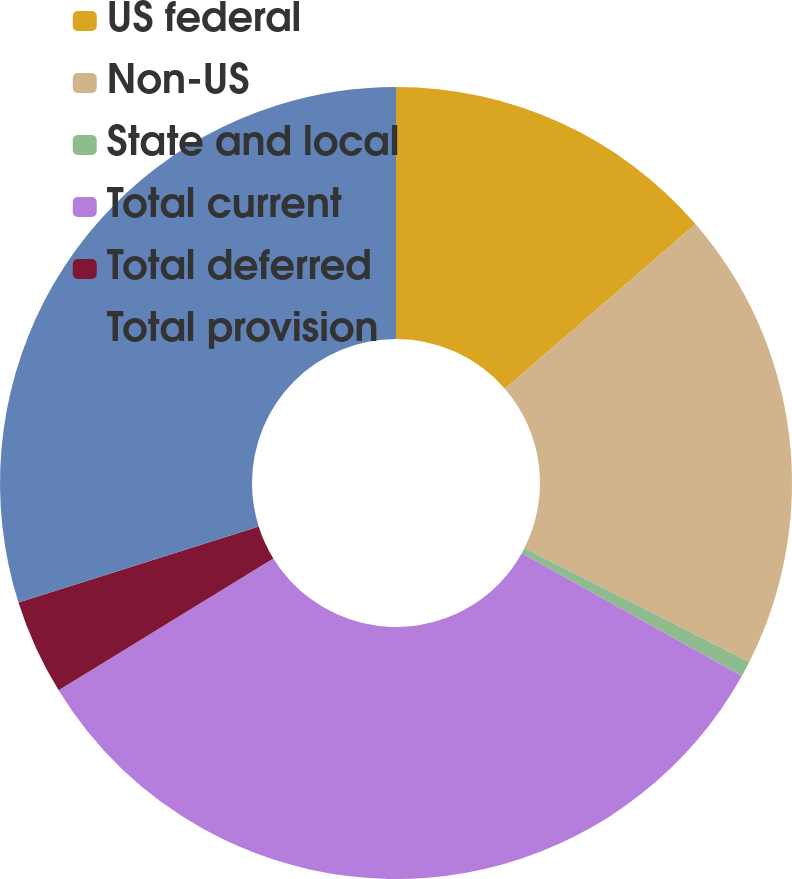<chart> <loc_0><loc_0><loc_500><loc_500><pie_chart><fcel>US federal<fcel>Non-US<fcel>State and local<fcel>Total current<fcel>Total deferred<fcel>Total provision<nl><fcel>13.65%<fcel>18.81%<fcel>0.64%<fcel>33.13%<fcel>3.89%<fcel>29.88%<nl></chart> 